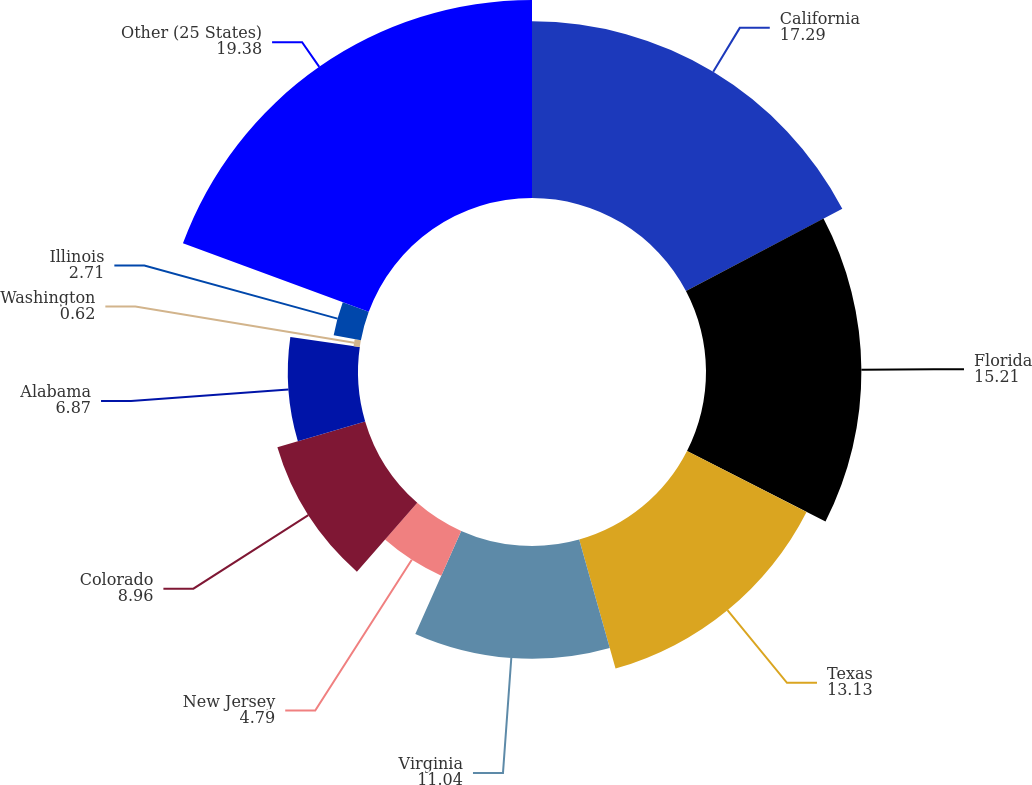Convert chart to OTSL. <chart><loc_0><loc_0><loc_500><loc_500><pie_chart><fcel>California<fcel>Florida<fcel>Texas<fcel>Virginia<fcel>New Jersey<fcel>Colorado<fcel>Alabama<fcel>Washington<fcel>Illinois<fcel>Other (25 States)<nl><fcel>17.29%<fcel>15.21%<fcel>13.13%<fcel>11.04%<fcel>4.79%<fcel>8.96%<fcel>6.87%<fcel>0.62%<fcel>2.71%<fcel>19.38%<nl></chart> 